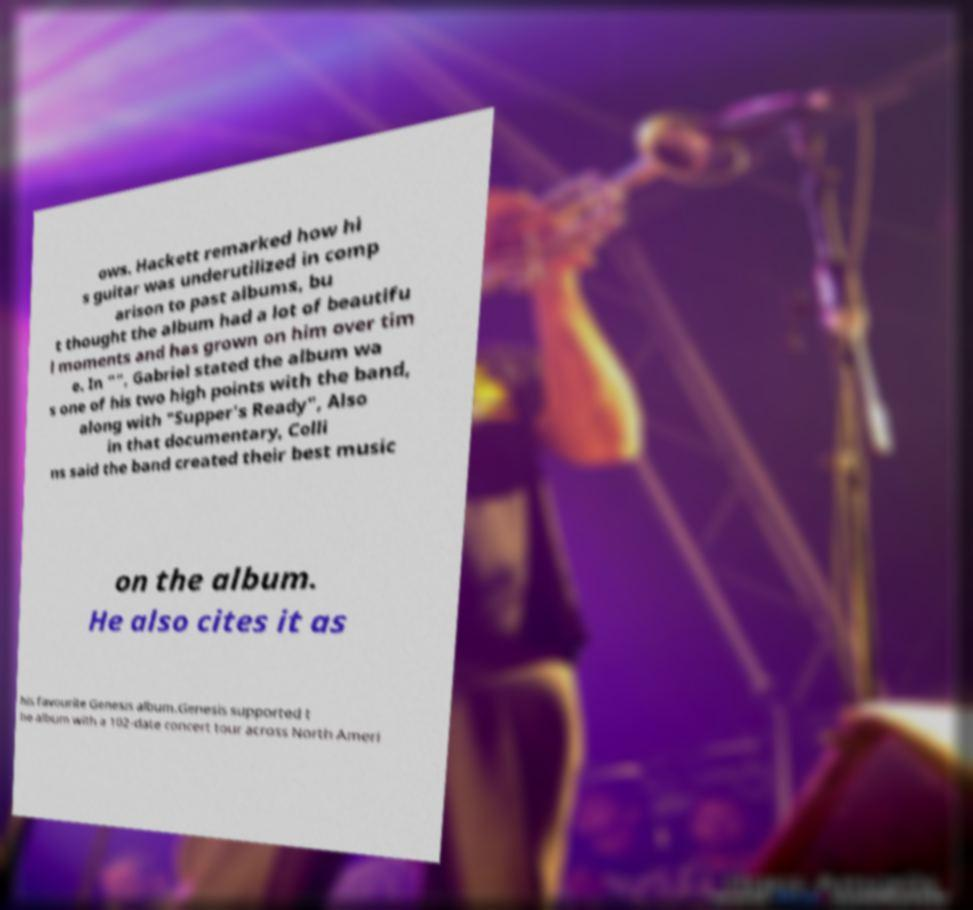For documentation purposes, I need the text within this image transcribed. Could you provide that? ows. Hackett remarked how hi s guitar was underutilized in comp arison to past albums, bu t thought the album had a lot of beautifu l moments and has grown on him over tim e. In "", Gabriel stated the album wa s one of his two high points with the band, along with "Supper's Ready", Also in that documentary, Colli ns said the band created their best music on the album. He also cites it as his favourite Genesis album.Genesis supported t he album with a 102-date concert tour across North Ameri 